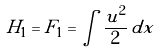Convert formula to latex. <formula><loc_0><loc_0><loc_500><loc_500>H _ { 1 } = F _ { 1 } = \int \frac { u ^ { 2 } } { 2 } \, d x</formula> 